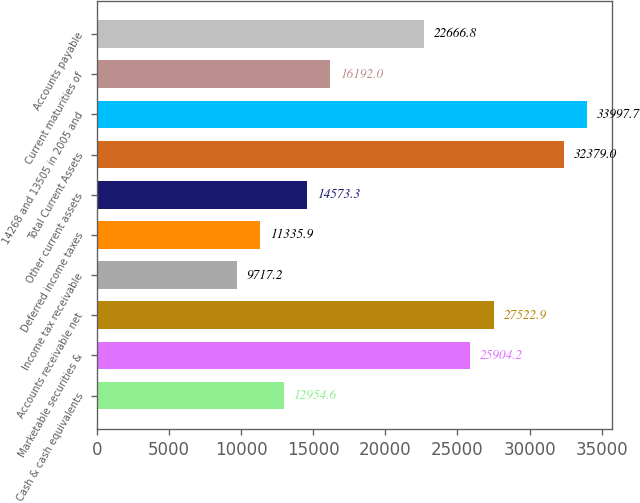Convert chart. <chart><loc_0><loc_0><loc_500><loc_500><bar_chart><fcel>Cash & cash equivalents<fcel>Marketable securities &<fcel>Accounts receivable net<fcel>Income tax receivable<fcel>Deferred income taxes<fcel>Other current assets<fcel>Total Current Assets<fcel>14268 and 13505 in 2005 and<fcel>Current maturities of<fcel>Accounts payable<nl><fcel>12954.6<fcel>25904.2<fcel>27522.9<fcel>9717.2<fcel>11335.9<fcel>14573.3<fcel>32379<fcel>33997.7<fcel>16192<fcel>22666.8<nl></chart> 